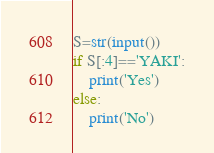Convert code to text. <code><loc_0><loc_0><loc_500><loc_500><_Python_>S=str(input())
if S[:4]=='YAKI':
    print('Yes')
else:
    print('No')
</code> 